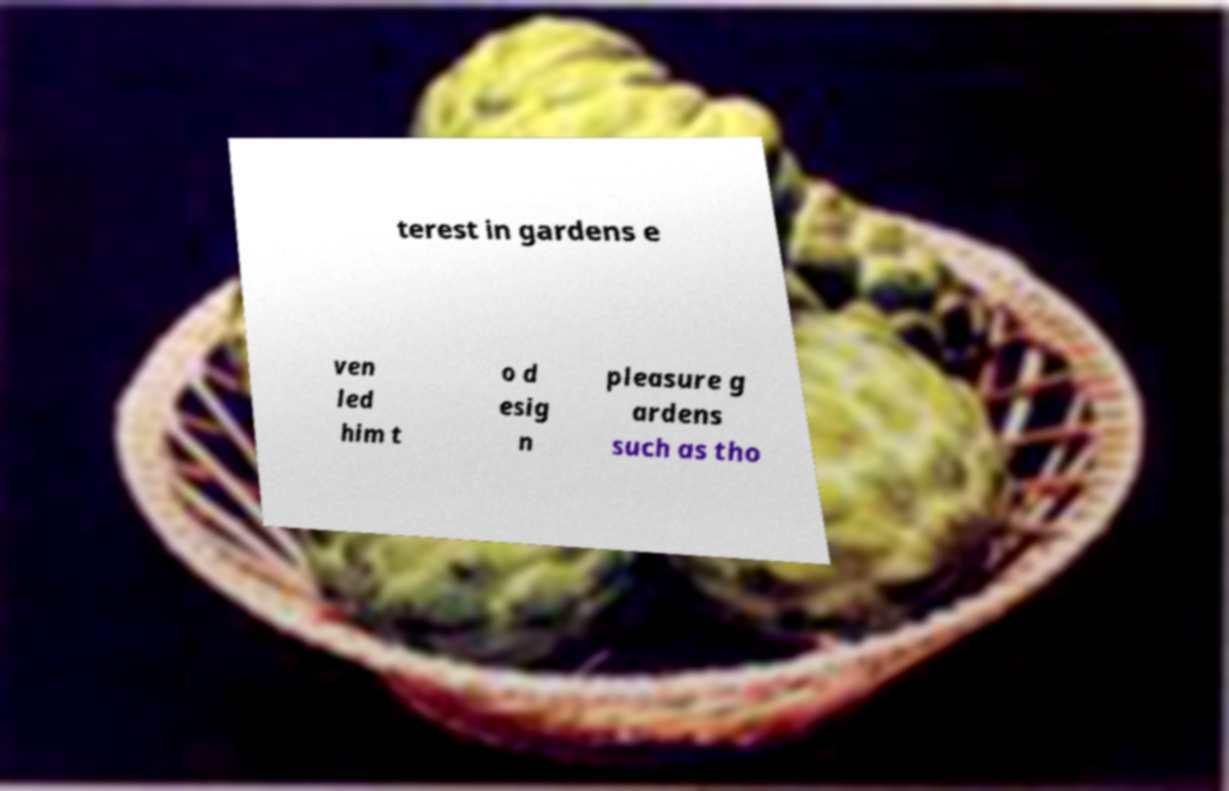What messages or text are displayed in this image? I need them in a readable, typed format. terest in gardens e ven led him t o d esig n pleasure g ardens such as tho 